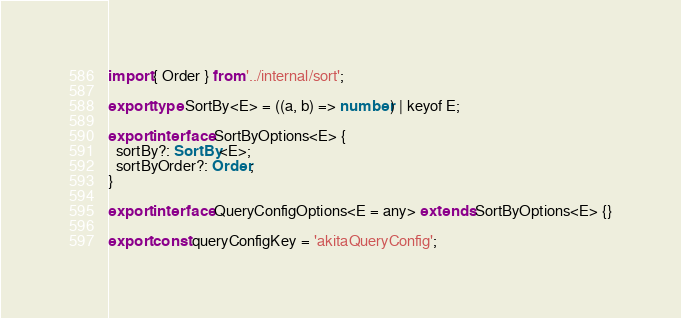<code> <loc_0><loc_0><loc_500><loc_500><_TypeScript_>import { Order } from '../internal/sort';

export type SortBy<E> = ((a, b) => number) | keyof E;

export interface SortByOptions<E> {
  sortBy?: SortBy<E>;
  sortByOrder?: Order;
}

export interface QueryConfigOptions<E = any> extends SortByOptions<E> {}

export const queryConfigKey = 'akitaQueryConfig';
</code> 